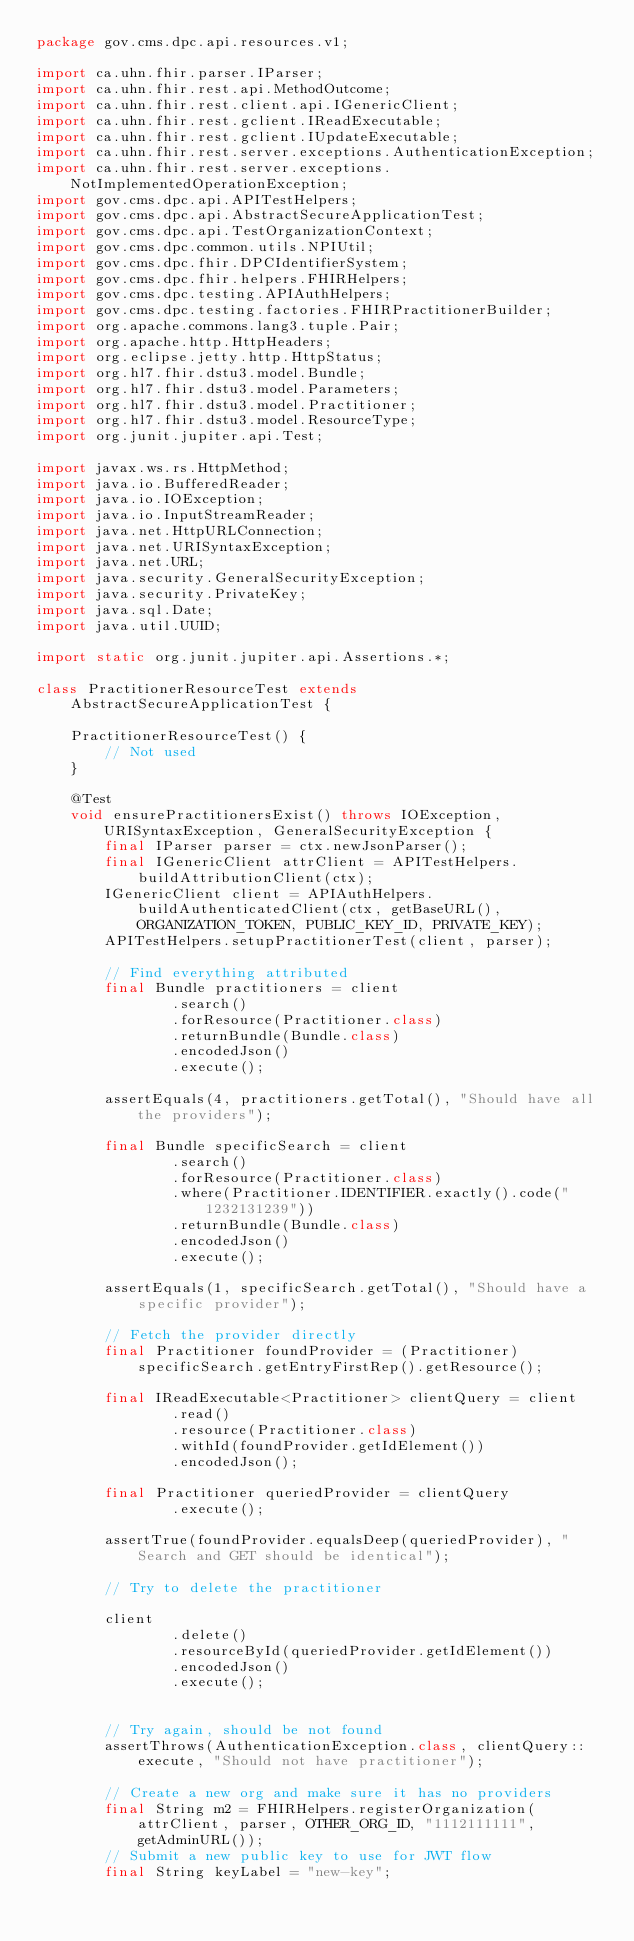<code> <loc_0><loc_0><loc_500><loc_500><_Java_>package gov.cms.dpc.api.resources.v1;

import ca.uhn.fhir.parser.IParser;
import ca.uhn.fhir.rest.api.MethodOutcome;
import ca.uhn.fhir.rest.client.api.IGenericClient;
import ca.uhn.fhir.rest.gclient.IReadExecutable;
import ca.uhn.fhir.rest.gclient.IUpdateExecutable;
import ca.uhn.fhir.rest.server.exceptions.AuthenticationException;
import ca.uhn.fhir.rest.server.exceptions.NotImplementedOperationException;
import gov.cms.dpc.api.APITestHelpers;
import gov.cms.dpc.api.AbstractSecureApplicationTest;
import gov.cms.dpc.api.TestOrganizationContext;
import gov.cms.dpc.common.utils.NPIUtil;
import gov.cms.dpc.fhir.DPCIdentifierSystem;
import gov.cms.dpc.fhir.helpers.FHIRHelpers;
import gov.cms.dpc.testing.APIAuthHelpers;
import gov.cms.dpc.testing.factories.FHIRPractitionerBuilder;
import org.apache.commons.lang3.tuple.Pair;
import org.apache.http.HttpHeaders;
import org.eclipse.jetty.http.HttpStatus;
import org.hl7.fhir.dstu3.model.Bundle;
import org.hl7.fhir.dstu3.model.Parameters;
import org.hl7.fhir.dstu3.model.Practitioner;
import org.hl7.fhir.dstu3.model.ResourceType;
import org.junit.jupiter.api.Test;

import javax.ws.rs.HttpMethod;
import java.io.BufferedReader;
import java.io.IOException;
import java.io.InputStreamReader;
import java.net.HttpURLConnection;
import java.net.URISyntaxException;
import java.net.URL;
import java.security.GeneralSecurityException;
import java.security.PrivateKey;
import java.sql.Date;
import java.util.UUID;

import static org.junit.jupiter.api.Assertions.*;

class PractitionerResourceTest extends AbstractSecureApplicationTest {

    PractitionerResourceTest() {
        // Not used
    }

    @Test
    void ensurePractitionersExist() throws IOException, URISyntaxException, GeneralSecurityException {
        final IParser parser = ctx.newJsonParser();
        final IGenericClient attrClient = APITestHelpers.buildAttributionClient(ctx);
        IGenericClient client = APIAuthHelpers.buildAuthenticatedClient(ctx, getBaseURL(), ORGANIZATION_TOKEN, PUBLIC_KEY_ID, PRIVATE_KEY);
        APITestHelpers.setupPractitionerTest(client, parser);

        // Find everything attributed
        final Bundle practitioners = client
                .search()
                .forResource(Practitioner.class)
                .returnBundle(Bundle.class)
                .encodedJson()
                .execute();

        assertEquals(4, practitioners.getTotal(), "Should have all the providers");

        final Bundle specificSearch = client
                .search()
                .forResource(Practitioner.class)
                .where(Practitioner.IDENTIFIER.exactly().code("1232131239"))
                .returnBundle(Bundle.class)
                .encodedJson()
                .execute();

        assertEquals(1, specificSearch.getTotal(), "Should have a specific provider");

        // Fetch the provider directly
        final Practitioner foundProvider = (Practitioner) specificSearch.getEntryFirstRep().getResource();

        final IReadExecutable<Practitioner> clientQuery = client
                .read()
                .resource(Practitioner.class)
                .withId(foundProvider.getIdElement())
                .encodedJson();

        final Practitioner queriedProvider = clientQuery
                .execute();

        assertTrue(foundProvider.equalsDeep(queriedProvider), "Search and GET should be identical");

        // Try to delete the practitioner

        client
                .delete()
                .resourceById(queriedProvider.getIdElement())
                .encodedJson()
                .execute();


        // Try again, should be not found
        assertThrows(AuthenticationException.class, clientQuery::execute, "Should not have practitioner");

        // Create a new org and make sure it has no providers
        final String m2 = FHIRHelpers.registerOrganization(attrClient, parser, OTHER_ORG_ID, "1112111111", getAdminURL());
        // Submit a new public key to use for JWT flow
        final String keyLabel = "new-key";</code> 